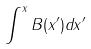Convert formula to latex. <formula><loc_0><loc_0><loc_500><loc_500>\int ^ { x } B ( x ^ { \prime } ) d x ^ { \prime }</formula> 